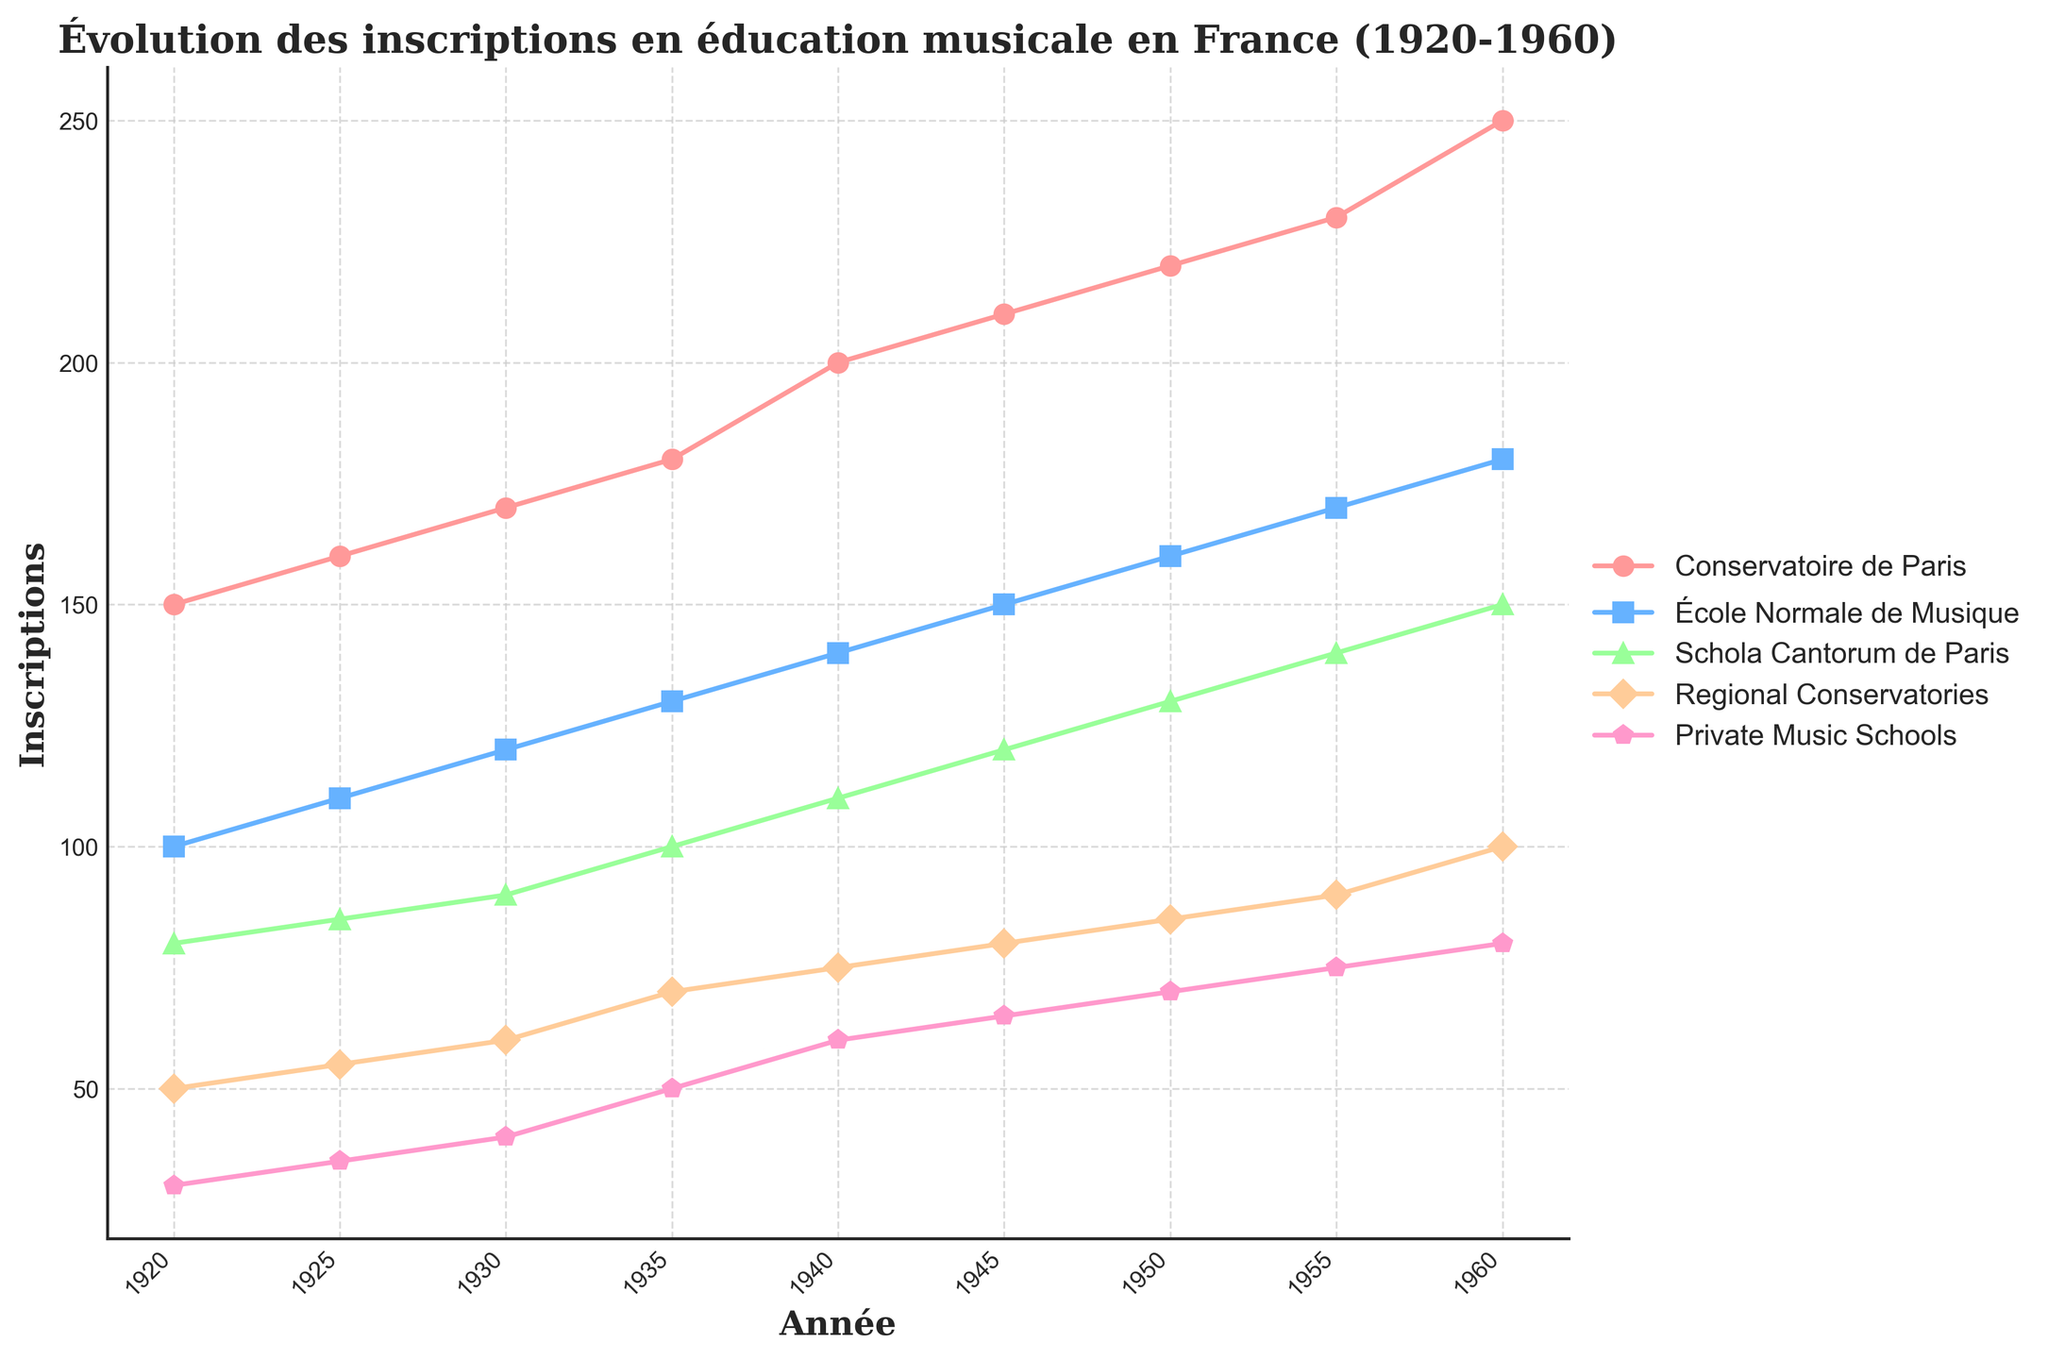What is the title of the plot? The title is displayed at the top of the plot, summarizing its main subject.
Answer: Évolution des inscriptions en éducation musicale en France (1920-1960) What are the axes labels of the plot? The x-axis label is located at the bottom of the plot, representing the years. The y-axis label is on the left side, indicating the number of enrollments.
Answer: Année, Inscriptions Which institution had the highest number of enrollments in 1960? By visually inspecting the plot and identifying the highest line in 1960, we see that the "Conservatoire de Paris" had the highest enrollments.
Answer: Conservatoire de Paris What are the markers used for the “Regional Conservatories” in the plot? The markers for each institution are different; inspecting the corresponding line for “Regional Conservatories” shows that the markers used are diamonds.
Answer: Diamond How many institutions are tracked in the plot? Counting the different lines and their respective labels in the legend reveals there are five institutions.
Answer: Five Which institution showed the largest increase in enrollments from 1920 to 1960? Checking the starting and ending points for each institution, the one with the most significant rise is the "Conservatoire de Paris" (from 150 to 250 enrollments).
Answer: Conservatoire de Paris What is the difference in enrollments between "École Normale de Musique" and "Schola Cantorum de Paris" in 1930? From the plot, the enrollments for "École Normale de Musique" are 120, and for "Schola Cantorum de Paris" are 90, so the difference is 120 - 90.
Answer: 30 Which institution had the least growth between 1920 and 1960? The institution with the smallest increase can be identified by examining the vertical difference; "Private Music Schools" increased from 30 to 80 enrollments.
Answer: Private Music Schools At which years do all institutions show an upward trend with no exception? Each line in the plot moves upward without any dips during the intervals. By examining all the years, we see this upward trend uninterrupted from 1920 to 1960.
Answer: All years 